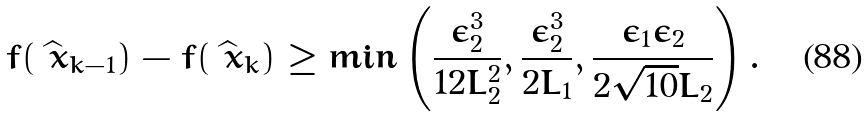<formula> <loc_0><loc_0><loc_500><loc_500>f ( \widehat { \ x } _ { k - 1 } ) - f ( \widehat { \ x } _ { k } ) \geq \min \left ( \frac { \epsilon _ { 2 } ^ { 3 } } { 1 2 L _ { 2 } ^ { 2 } } , \frac { \epsilon _ { 2 } ^ { 3 } } { 2 L _ { 1 } } , \frac { \epsilon _ { 1 } \epsilon _ { 2 } } { 2 \sqrt { 1 0 } L _ { 2 } } \right ) .</formula> 